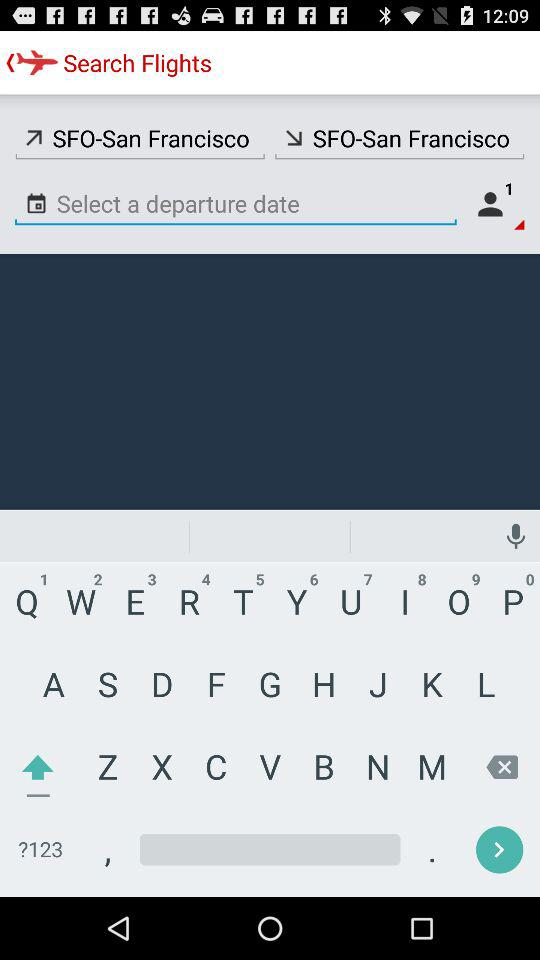What is the number of passengers? The number of passengers is 1. 